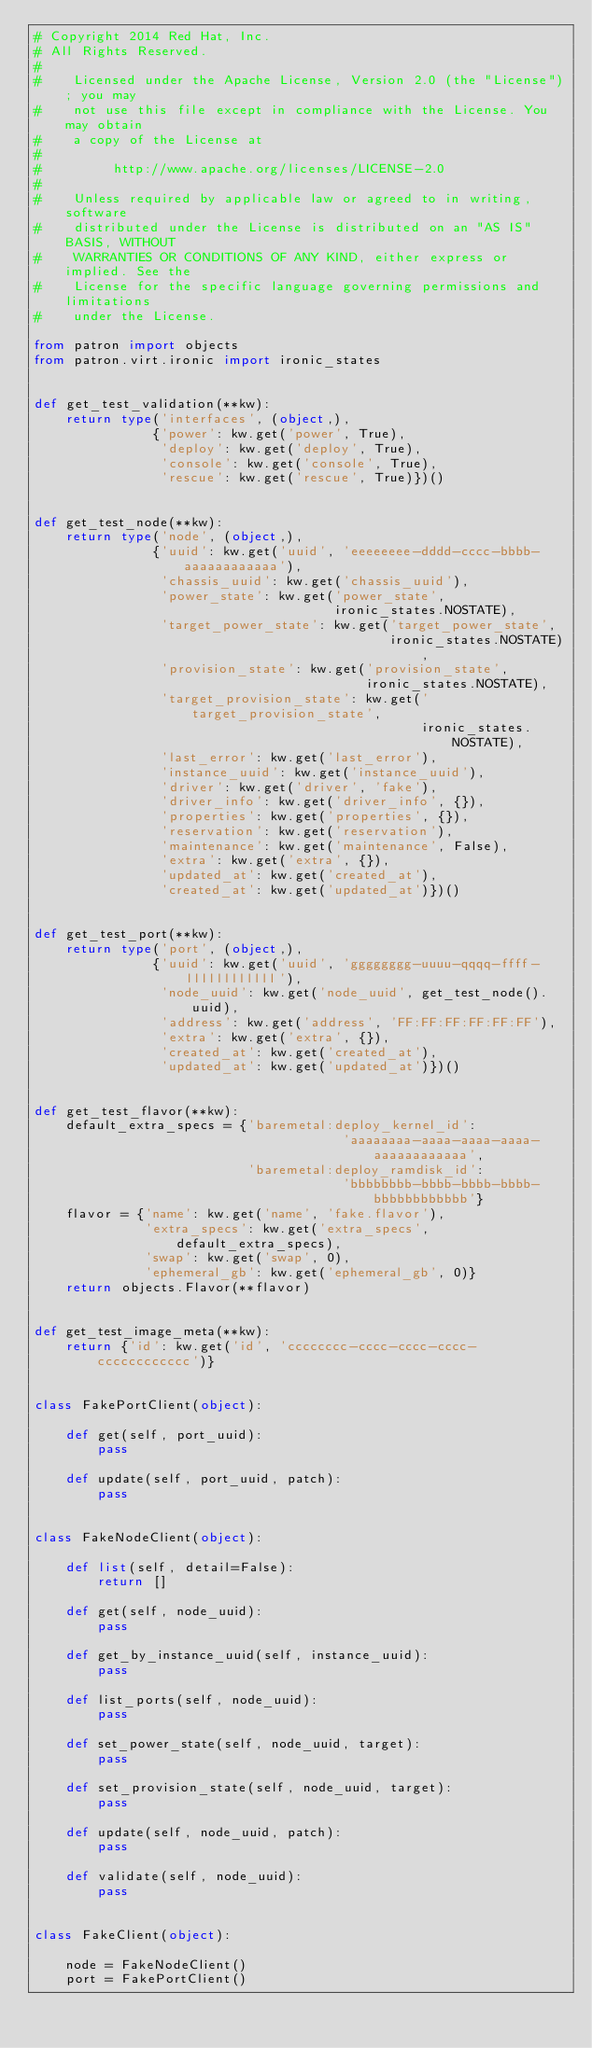Convert code to text. <code><loc_0><loc_0><loc_500><loc_500><_Python_># Copyright 2014 Red Hat, Inc.
# All Rights Reserved.
#
#    Licensed under the Apache License, Version 2.0 (the "License"); you may
#    not use this file except in compliance with the License. You may obtain
#    a copy of the License at
#
#         http://www.apache.org/licenses/LICENSE-2.0
#
#    Unless required by applicable law or agreed to in writing, software
#    distributed under the License is distributed on an "AS IS" BASIS, WITHOUT
#    WARRANTIES OR CONDITIONS OF ANY KIND, either express or implied. See the
#    License for the specific language governing permissions and limitations
#    under the License.

from patron import objects
from patron.virt.ironic import ironic_states


def get_test_validation(**kw):
    return type('interfaces', (object,),
               {'power': kw.get('power', True),
                'deploy': kw.get('deploy', True),
                'console': kw.get('console', True),
                'rescue': kw.get('rescue', True)})()


def get_test_node(**kw):
    return type('node', (object,),
               {'uuid': kw.get('uuid', 'eeeeeeee-dddd-cccc-bbbb-aaaaaaaaaaaa'),
                'chassis_uuid': kw.get('chassis_uuid'),
                'power_state': kw.get('power_state',
                                      ironic_states.NOSTATE),
                'target_power_state': kw.get('target_power_state',
                                             ironic_states.NOSTATE),
                'provision_state': kw.get('provision_state',
                                          ironic_states.NOSTATE),
                'target_provision_state': kw.get('target_provision_state',
                                                 ironic_states.NOSTATE),
                'last_error': kw.get('last_error'),
                'instance_uuid': kw.get('instance_uuid'),
                'driver': kw.get('driver', 'fake'),
                'driver_info': kw.get('driver_info', {}),
                'properties': kw.get('properties', {}),
                'reservation': kw.get('reservation'),
                'maintenance': kw.get('maintenance', False),
                'extra': kw.get('extra', {}),
                'updated_at': kw.get('created_at'),
                'created_at': kw.get('updated_at')})()


def get_test_port(**kw):
    return type('port', (object,),
               {'uuid': kw.get('uuid', 'gggggggg-uuuu-qqqq-ffff-llllllllllll'),
                'node_uuid': kw.get('node_uuid', get_test_node().uuid),
                'address': kw.get('address', 'FF:FF:FF:FF:FF:FF'),
                'extra': kw.get('extra', {}),
                'created_at': kw.get('created_at'),
                'updated_at': kw.get('updated_at')})()


def get_test_flavor(**kw):
    default_extra_specs = {'baremetal:deploy_kernel_id':
                                       'aaaaaaaa-aaaa-aaaa-aaaa-aaaaaaaaaaaa',
                           'baremetal:deploy_ramdisk_id':
                                       'bbbbbbbb-bbbb-bbbb-bbbb-bbbbbbbbbbbb'}
    flavor = {'name': kw.get('name', 'fake.flavor'),
              'extra_specs': kw.get('extra_specs', default_extra_specs),
              'swap': kw.get('swap', 0),
              'ephemeral_gb': kw.get('ephemeral_gb', 0)}
    return objects.Flavor(**flavor)


def get_test_image_meta(**kw):
    return {'id': kw.get('id', 'cccccccc-cccc-cccc-cccc-cccccccccccc')}


class FakePortClient(object):

    def get(self, port_uuid):
        pass

    def update(self, port_uuid, patch):
        pass


class FakeNodeClient(object):

    def list(self, detail=False):
        return []

    def get(self, node_uuid):
        pass

    def get_by_instance_uuid(self, instance_uuid):
        pass

    def list_ports(self, node_uuid):
        pass

    def set_power_state(self, node_uuid, target):
        pass

    def set_provision_state(self, node_uuid, target):
        pass

    def update(self, node_uuid, patch):
        pass

    def validate(self, node_uuid):
        pass


class FakeClient(object):

    node = FakeNodeClient()
    port = FakePortClient()
</code> 